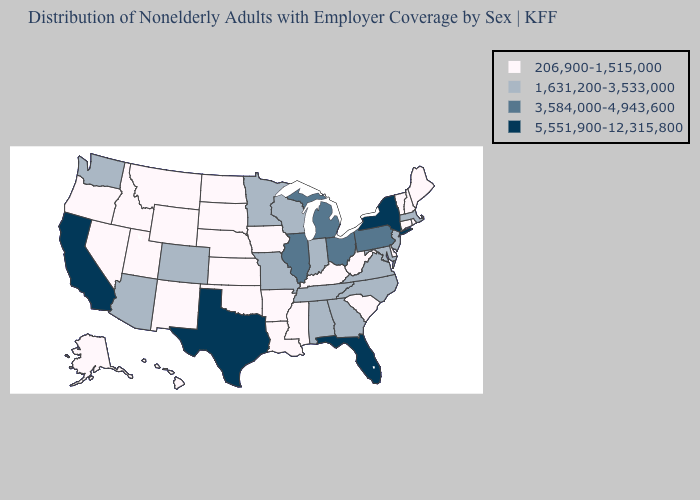What is the value of Arkansas?
Answer briefly. 206,900-1,515,000. Among the states that border Massachusetts , does New York have the highest value?
Keep it brief. Yes. Does Texas have the highest value in the USA?
Write a very short answer. Yes. What is the lowest value in the USA?
Quick response, please. 206,900-1,515,000. What is the value of Virginia?
Write a very short answer. 1,631,200-3,533,000. What is the value of Maine?
Write a very short answer. 206,900-1,515,000. Name the states that have a value in the range 206,900-1,515,000?
Quick response, please. Alaska, Arkansas, Connecticut, Delaware, Hawaii, Idaho, Iowa, Kansas, Kentucky, Louisiana, Maine, Mississippi, Montana, Nebraska, Nevada, New Hampshire, New Mexico, North Dakota, Oklahoma, Oregon, Rhode Island, South Carolina, South Dakota, Utah, Vermont, West Virginia, Wyoming. What is the highest value in the USA?
Concise answer only. 5,551,900-12,315,800. Does Massachusetts have the lowest value in the USA?
Be succinct. No. Name the states that have a value in the range 1,631,200-3,533,000?
Concise answer only. Alabama, Arizona, Colorado, Georgia, Indiana, Maryland, Massachusetts, Minnesota, Missouri, New Jersey, North Carolina, Tennessee, Virginia, Washington, Wisconsin. Among the states that border Nevada , which have the highest value?
Write a very short answer. California. What is the highest value in the USA?
Answer briefly. 5,551,900-12,315,800. What is the value of Alabama?
Answer briefly. 1,631,200-3,533,000. Does the map have missing data?
Quick response, please. No. Name the states that have a value in the range 1,631,200-3,533,000?
Answer briefly. Alabama, Arizona, Colorado, Georgia, Indiana, Maryland, Massachusetts, Minnesota, Missouri, New Jersey, North Carolina, Tennessee, Virginia, Washington, Wisconsin. 